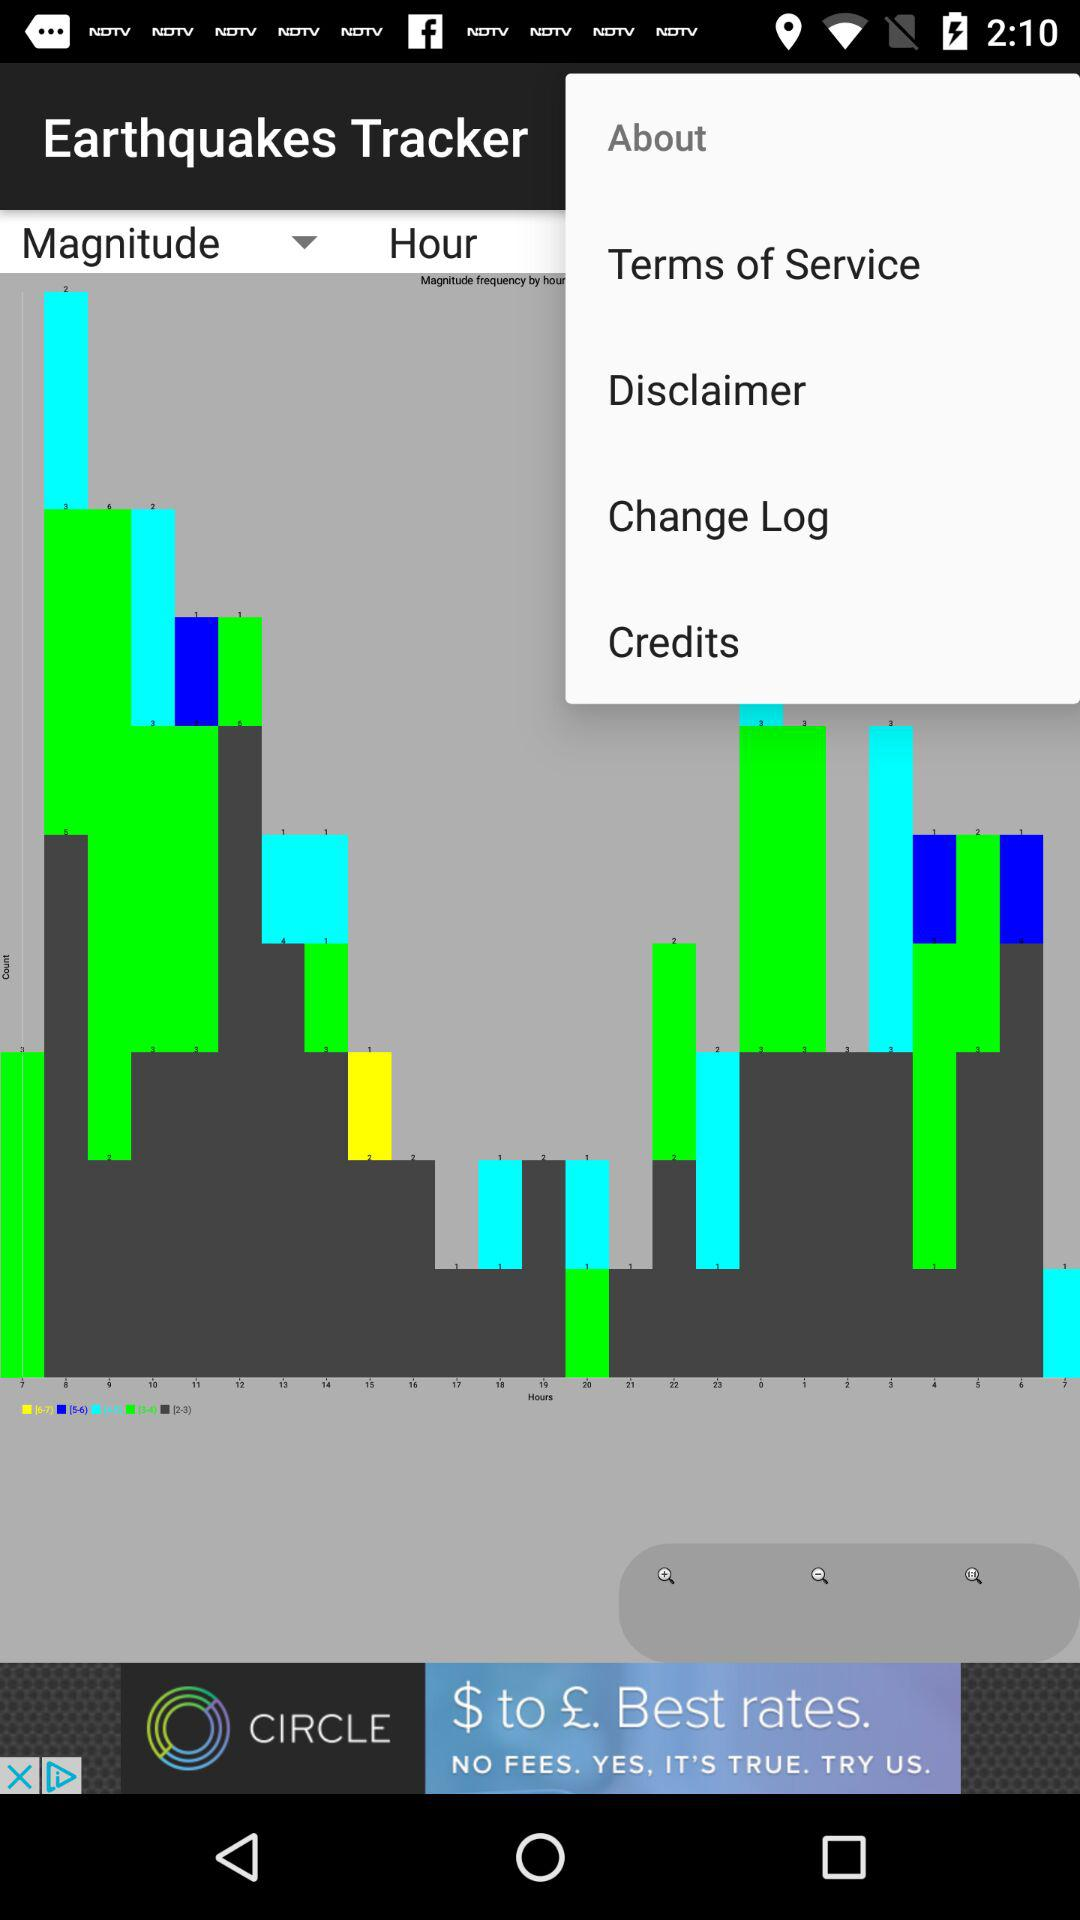Has the user agreed to the terms of service?
When the provided information is insufficient, respond with <no answer>. <no answer> 